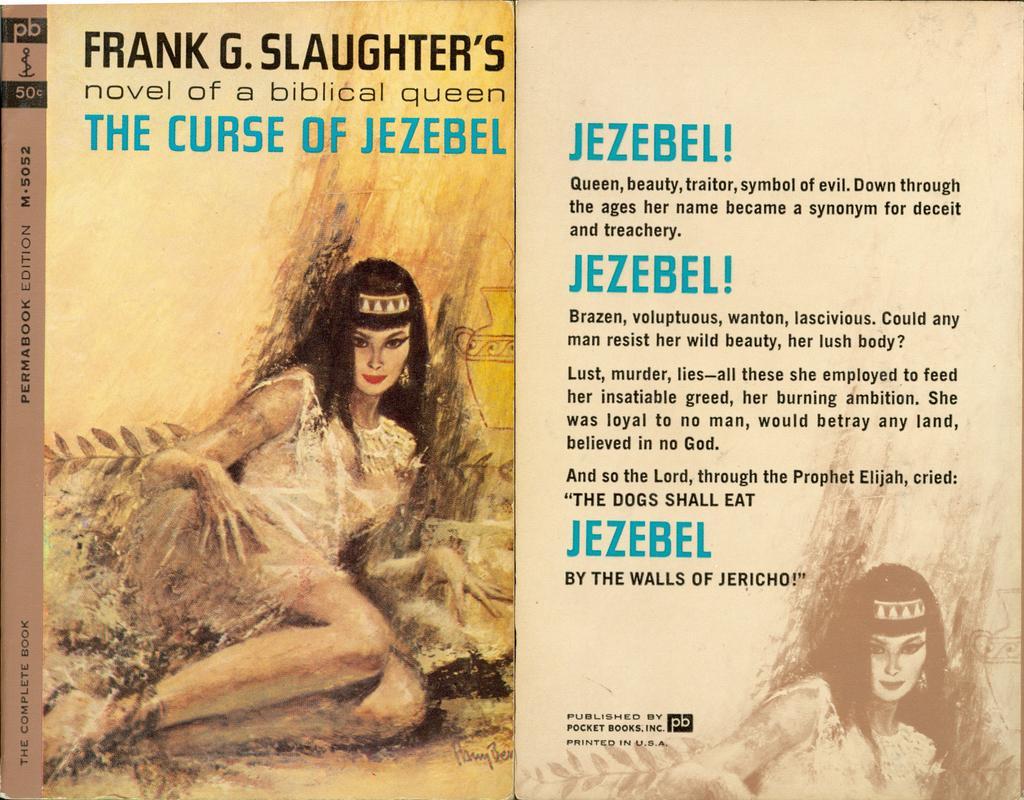How would you summarize this image in a sentence or two? In this picture I can see there is a woman lying and she is wearing a white dress and a crown. There is something written at the top of the book and this is a cover page and there is another picture on to left and there is something written on it. 